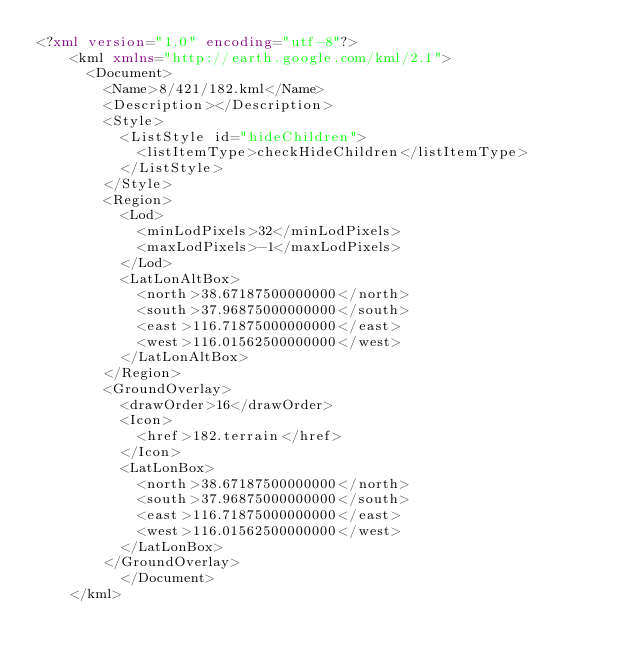Convert code to text. <code><loc_0><loc_0><loc_500><loc_500><_XML_><?xml version="1.0" encoding="utf-8"?>
	<kml xmlns="http://earth.google.com/kml/2.1">
	  <Document>
	    <Name>8/421/182.kml</Name>
	    <Description></Description>
	    <Style>
	      <ListStyle id="hideChildren">
	        <listItemType>checkHideChildren</listItemType>
	      </ListStyle>
	    </Style>
	    <Region>
	      <Lod>
	        <minLodPixels>32</minLodPixels>
	        <maxLodPixels>-1</maxLodPixels>
	      </Lod>
	      <LatLonAltBox>
	        <north>38.67187500000000</north>
	        <south>37.96875000000000</south>
	        <east>116.71875000000000</east>
	        <west>116.01562500000000</west>
	      </LatLonAltBox>
	    </Region>
	    <GroundOverlay>
	      <drawOrder>16</drawOrder>
	      <Icon>
	        <href>182.terrain</href>
	      </Icon>
	      <LatLonBox>
	        <north>38.67187500000000</north>
	        <south>37.96875000000000</south>
	        <east>116.71875000000000</east>
	        <west>116.01562500000000</west>
	      </LatLonBox>
	    </GroundOverlay>
		  </Document>
	</kml>
	</code> 